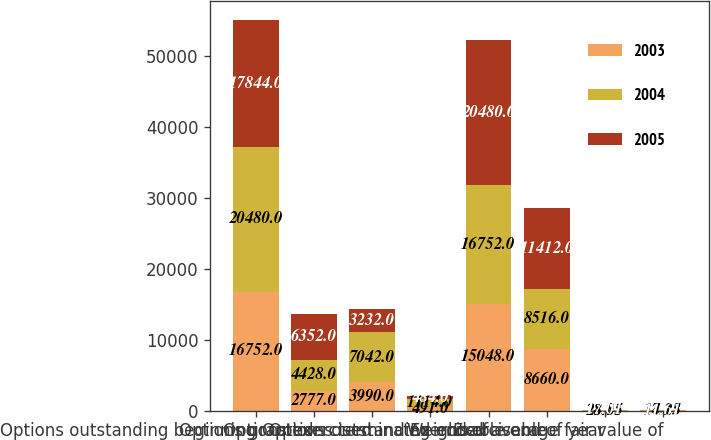Convert chart. <chart><loc_0><loc_0><loc_500><loc_500><stacked_bar_chart><ecel><fcel>Options outstanding beginning<fcel>Options granted<fcel>Options exercised<fcel>Options terminated<fcel>Options outstanding end of<fcel>Exercisable<fcel>Exercisable end of year<fcel>Weighted average fair value of<nl><fcel>2003<fcel>16752<fcel>2777<fcel>3990<fcel>491<fcel>15048<fcel>8660<fcel>28.81<fcel>14.15<nl><fcel>2004<fcel>20480<fcel>4428<fcel>7042<fcel>1114<fcel>16752<fcel>8516<fcel>23.95<fcel>17.23<nl><fcel>2005<fcel>17844<fcel>6352<fcel>3232<fcel>484<fcel>20480<fcel>11412<fcel>17.01<fcel>11.61<nl></chart> 